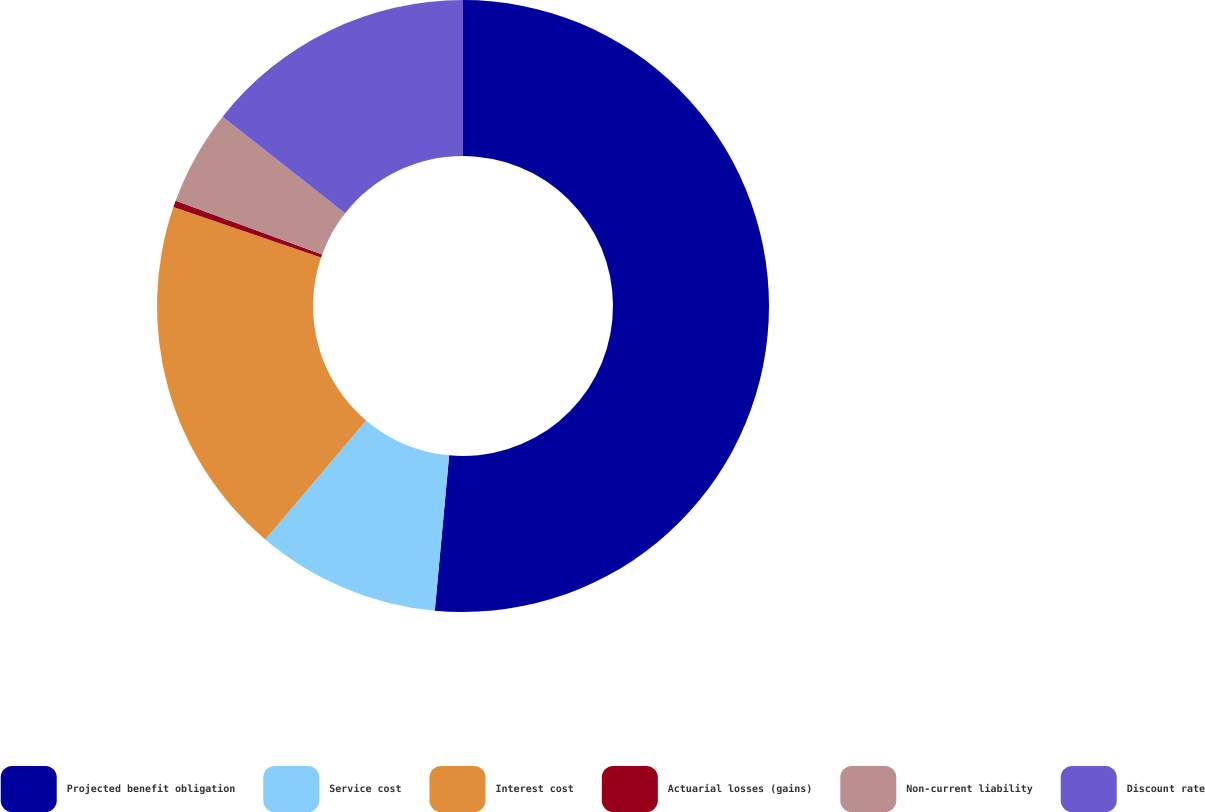<chart> <loc_0><loc_0><loc_500><loc_500><pie_chart><fcel>Projected benefit obligation<fcel>Service cost<fcel>Interest cost<fcel>Actuarial losses (gains)<fcel>Non-current liability<fcel>Discount rate<nl><fcel>51.47%<fcel>9.71%<fcel>19.06%<fcel>0.35%<fcel>5.03%<fcel>14.38%<nl></chart> 